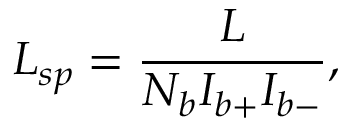<formula> <loc_0><loc_0><loc_500><loc_500>L _ { s p } = \frac { L } { N _ { b } I _ { b + } I _ { b - } } ,</formula> 